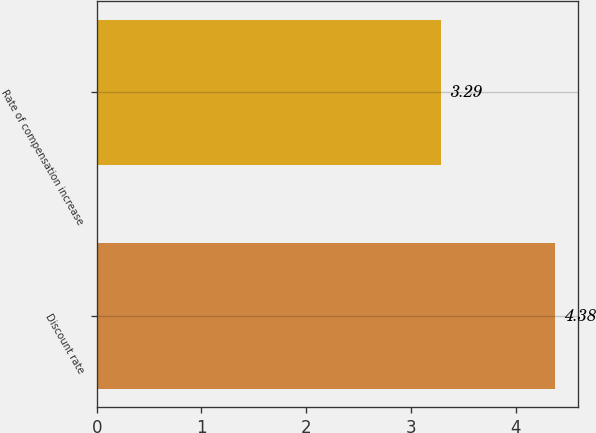<chart> <loc_0><loc_0><loc_500><loc_500><bar_chart><fcel>Discount rate<fcel>Rate of compensation increase<nl><fcel>4.38<fcel>3.29<nl></chart> 